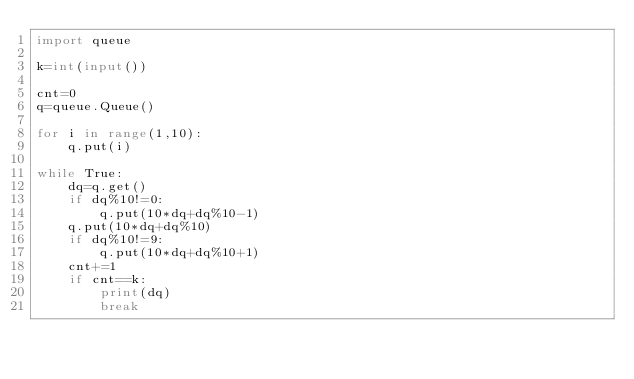<code> <loc_0><loc_0><loc_500><loc_500><_Python_>import queue

k=int(input())

cnt=0
q=queue.Queue()

for i in range(1,10):
    q.put(i)

while True:
    dq=q.get()
    if dq%10!=0:
        q.put(10*dq+dq%10-1)
    q.put(10*dq+dq%10)
    if dq%10!=9:
        q.put(10*dq+dq%10+1)
    cnt+=1
    if cnt==k:
        print(dq)
        break
    </code> 